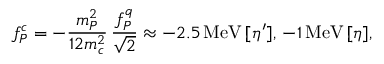<formula> <loc_0><loc_0><loc_500><loc_500>f _ { P } ^ { c } = - \frac { m _ { P } ^ { 2 } } { 1 2 m _ { c } ^ { 2 } } \, \frac { f _ { P } ^ { q } } { \sqrt { 2 } } \approx - 2 . 5 \, M e V \, [ \eta ^ { \prime } ] , \, - 1 \, M e V \, [ \eta ] ,</formula> 